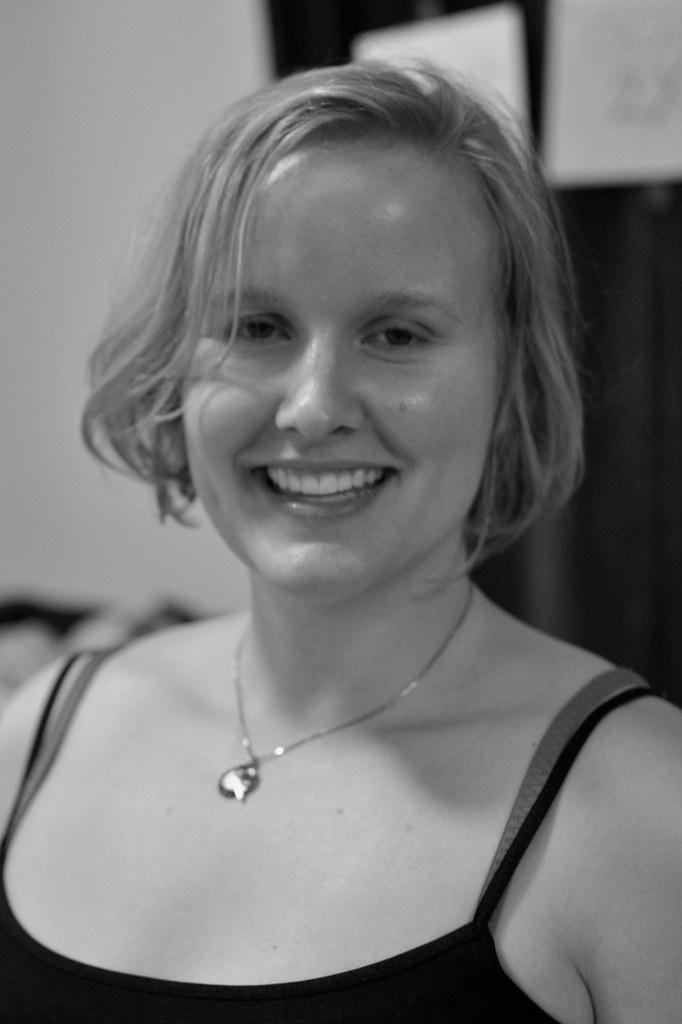Who is present in the image? There is a woman in the image. What is the woman wearing? The woman is wearing a black dress. What can be seen in the background of the image? There is a wall in the background of the image. What type of ray is swimming in the background of the image? There is no ray present in the image; it features a woman in a black dress with a wall in the background. 